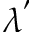Convert formula to latex. <formula><loc_0><loc_0><loc_500><loc_500>\lambda ^ { ^ { \prime } }</formula> 